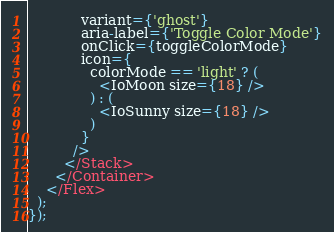Convert code to text. <code><loc_0><loc_0><loc_500><loc_500><_TypeScript_>            variant={'ghost'}
            aria-label={'Toggle Color Mode'}
            onClick={toggleColorMode}
            icon={
              colorMode == 'light' ? (
                <IoMoon size={18} />
              ) : (
                <IoSunny size={18} />
              )
            }
          />
        </Stack>
      </Container>
    </Flex>
  );
});
</code> 